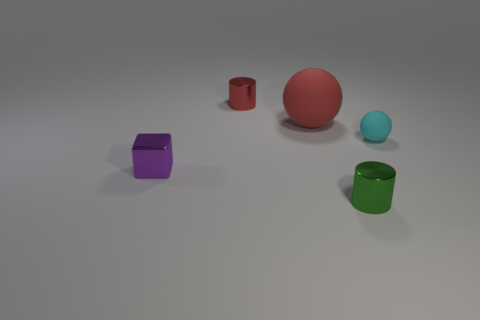Are the objects arranged in any particular pattern? The objects are dispersed with no discernible pattern, spacing, or alignment. They are spread out randomly on a flat surface, providing an aesthetically balanced display of forms and colors. 